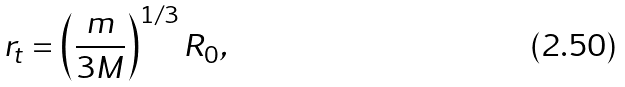<formula> <loc_0><loc_0><loc_500><loc_500>r _ { t } = \left ( \frac { m } { 3 M } \right ) ^ { 1 / 3 } R _ { 0 } ,</formula> 